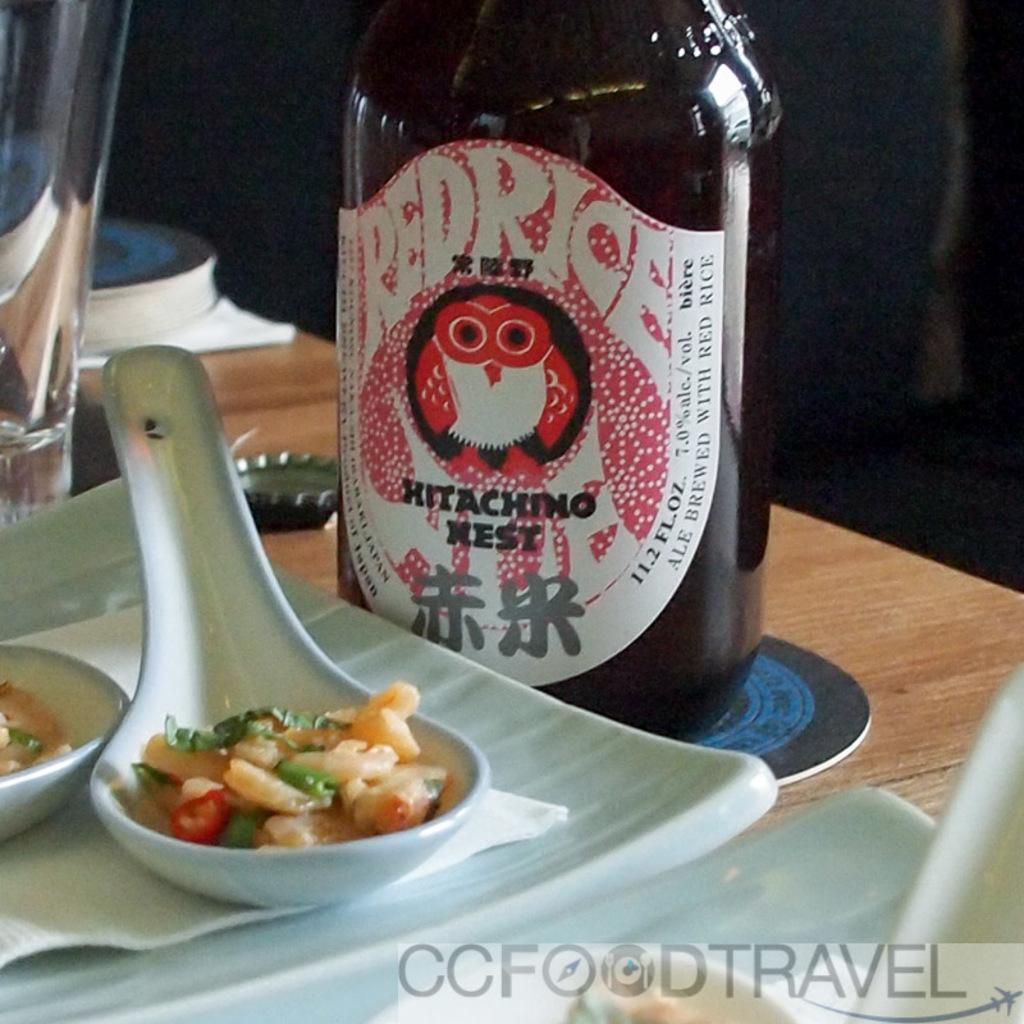<image>
Offer a succinct explanation of the picture presented. A bottle has the label Hitachino West and an owl on it. 